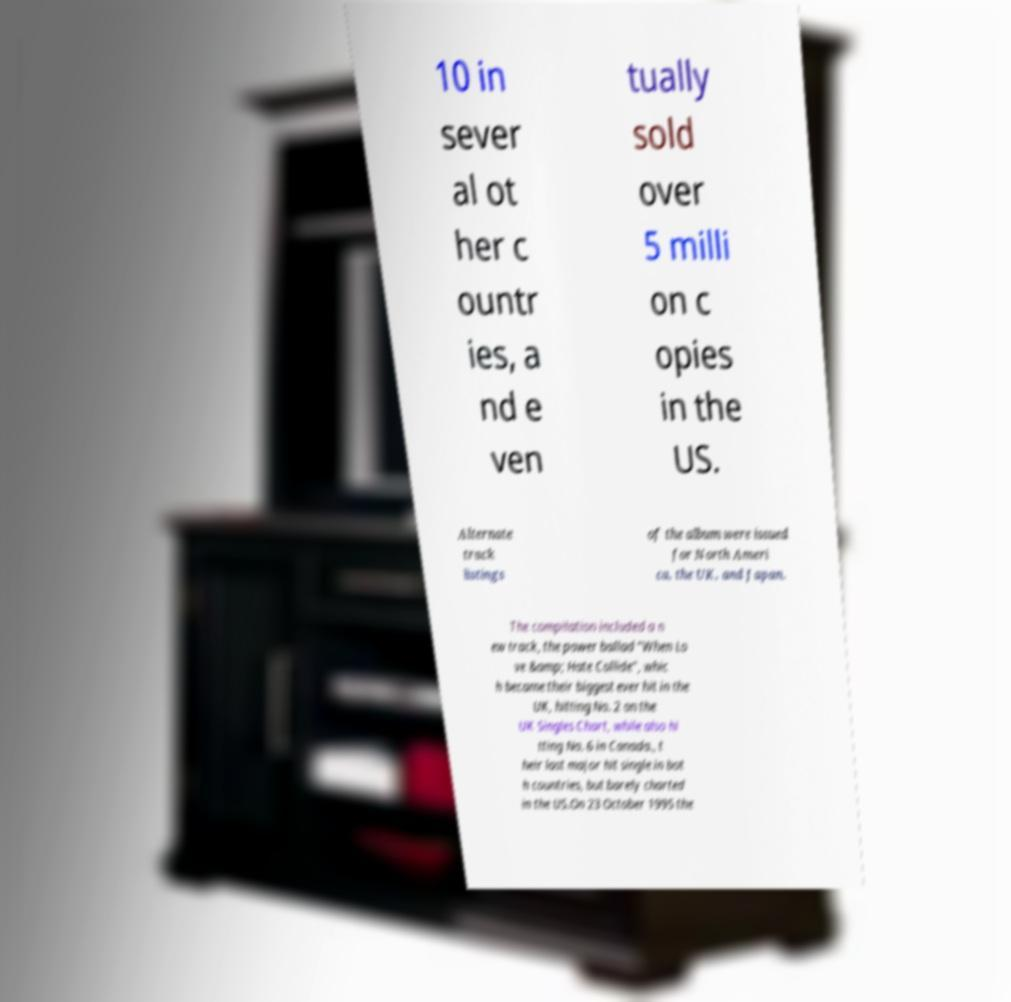There's text embedded in this image that I need extracted. Can you transcribe it verbatim? 10 in sever al ot her c ountr ies, a nd e ven tually sold over 5 milli on c opies in the US. Alternate track listings of the album were issued for North Ameri ca, the UK, and Japan. The compilation included a n ew track, the power ballad "When Lo ve &amp; Hate Collide", whic h became their biggest ever hit in the UK, hitting No. 2 on the UK Singles Chart, while also hi tting No. 6 in Canada., t heir last major hit single in bot h countries, but barely charted in the US.On 23 October 1995 the 